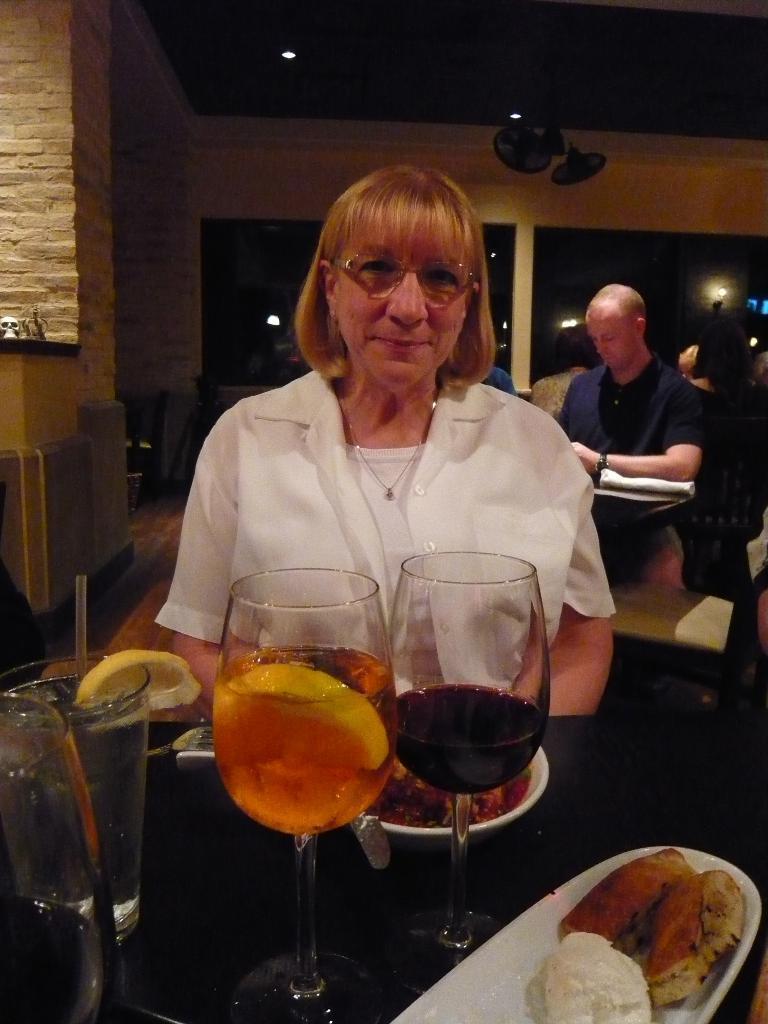Can you describe this image briefly? There is a woman,in front of this woman we can see glasses,plates and food on table. On the background we can see wall,persons,table and windows. On top we can see lights and fans. 